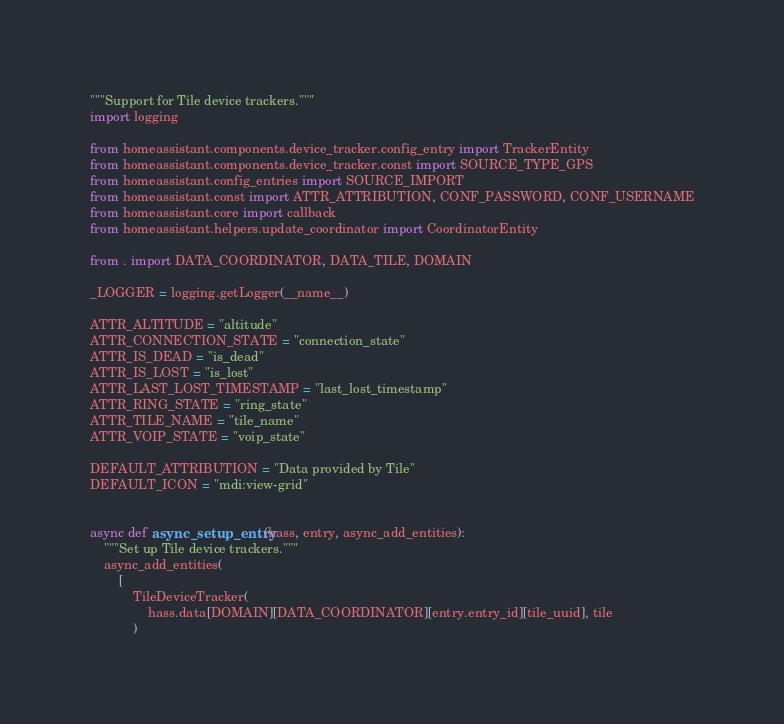Convert code to text. <code><loc_0><loc_0><loc_500><loc_500><_Python_>"""Support for Tile device trackers."""
import logging

from homeassistant.components.device_tracker.config_entry import TrackerEntity
from homeassistant.components.device_tracker.const import SOURCE_TYPE_GPS
from homeassistant.config_entries import SOURCE_IMPORT
from homeassistant.const import ATTR_ATTRIBUTION, CONF_PASSWORD, CONF_USERNAME
from homeassistant.core import callback
from homeassistant.helpers.update_coordinator import CoordinatorEntity

from . import DATA_COORDINATOR, DATA_TILE, DOMAIN

_LOGGER = logging.getLogger(__name__)

ATTR_ALTITUDE = "altitude"
ATTR_CONNECTION_STATE = "connection_state"
ATTR_IS_DEAD = "is_dead"
ATTR_IS_LOST = "is_lost"
ATTR_LAST_LOST_TIMESTAMP = "last_lost_timestamp"
ATTR_RING_STATE = "ring_state"
ATTR_TILE_NAME = "tile_name"
ATTR_VOIP_STATE = "voip_state"

DEFAULT_ATTRIBUTION = "Data provided by Tile"
DEFAULT_ICON = "mdi:view-grid"


async def async_setup_entry(hass, entry, async_add_entities):
    """Set up Tile device trackers."""
    async_add_entities(
        [
            TileDeviceTracker(
                hass.data[DOMAIN][DATA_COORDINATOR][entry.entry_id][tile_uuid], tile
            )</code> 